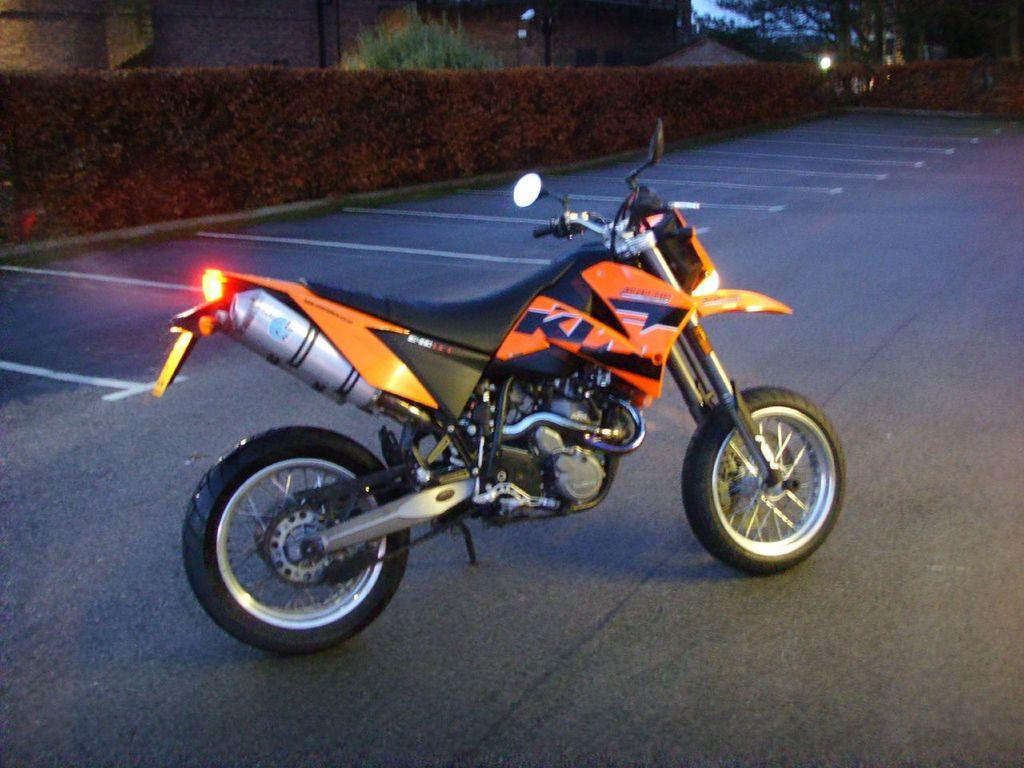What is parked on the road in the image? There is a bike parked on the road in the image. What can be seen in the background of the image? There are plants in the background of the image. What type of structure is visible at the top of the image? There is a building visible at the top of the image. What type of skirt is hanging on the bike in the image? There is no skirt present in the image; it features a bike parked on the road with plants in the background and a building visible at the top. 